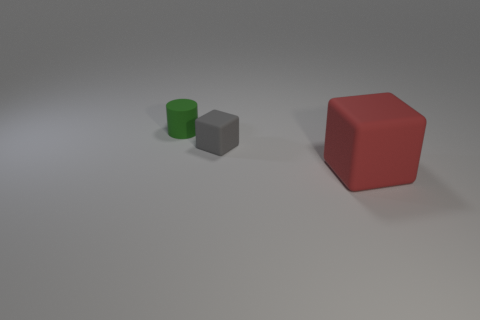What could be the purpose of this arrangement? This arrangement could be designed for an educational purpose, such as a visual aid for teaching geometry, spatial reasoning, or color identification, given the distinct shapes and colors of the objects. 